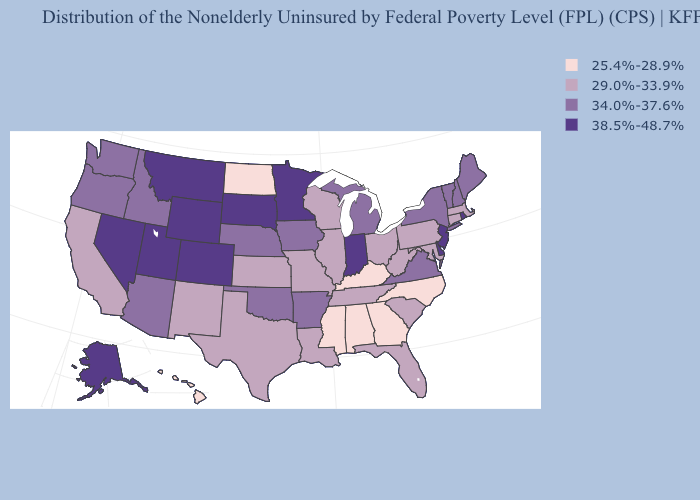What is the highest value in states that border West Virginia?
Short answer required. 34.0%-37.6%. Does Minnesota have the same value as Illinois?
Give a very brief answer. No. What is the highest value in the USA?
Give a very brief answer. 38.5%-48.7%. What is the value of Arkansas?
Concise answer only. 34.0%-37.6%. Name the states that have a value in the range 29.0%-33.9%?
Be succinct. California, Connecticut, Florida, Illinois, Kansas, Louisiana, Maryland, Massachusetts, Missouri, New Mexico, Ohio, Pennsylvania, South Carolina, Tennessee, Texas, West Virginia, Wisconsin. What is the value of Texas?
Give a very brief answer. 29.0%-33.9%. What is the lowest value in the South?
Short answer required. 25.4%-28.9%. What is the value of Delaware?
Short answer required. 38.5%-48.7%. Which states hav the highest value in the MidWest?
Keep it brief. Indiana, Minnesota, South Dakota. Among the states that border Arizona , which have the lowest value?
Quick response, please. California, New Mexico. Does Montana have the highest value in the West?
Write a very short answer. Yes. How many symbols are there in the legend?
Concise answer only. 4. Does New York have a lower value than Indiana?
Concise answer only. Yes. What is the value of Connecticut?
Give a very brief answer. 29.0%-33.9%. Does Rhode Island have the highest value in the USA?
Be succinct. Yes. 